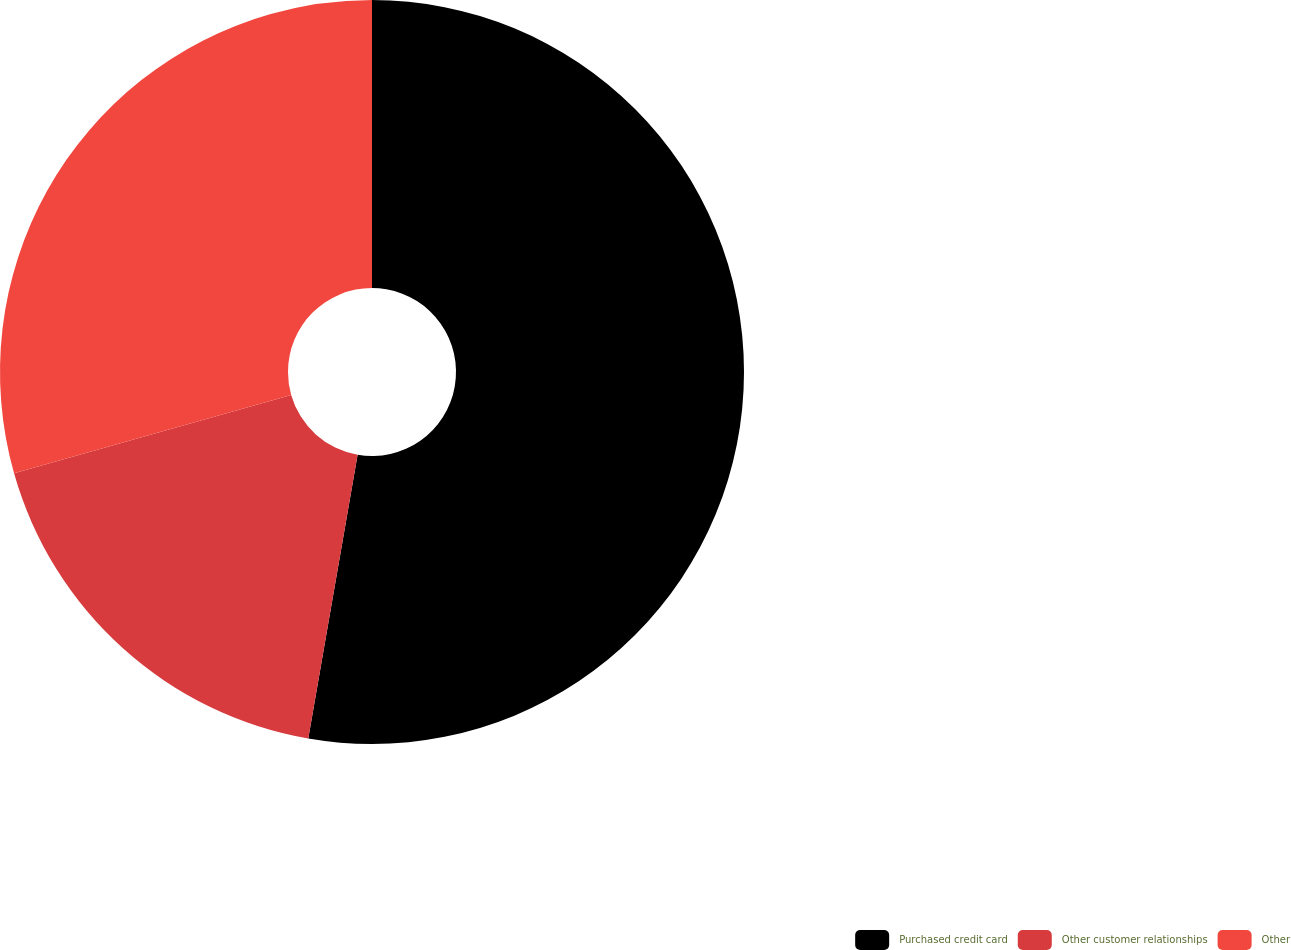Convert chart. <chart><loc_0><loc_0><loc_500><loc_500><pie_chart><fcel>Purchased credit card<fcel>Other customer relationships<fcel>Other<nl><fcel>52.74%<fcel>17.87%<fcel>29.39%<nl></chart> 